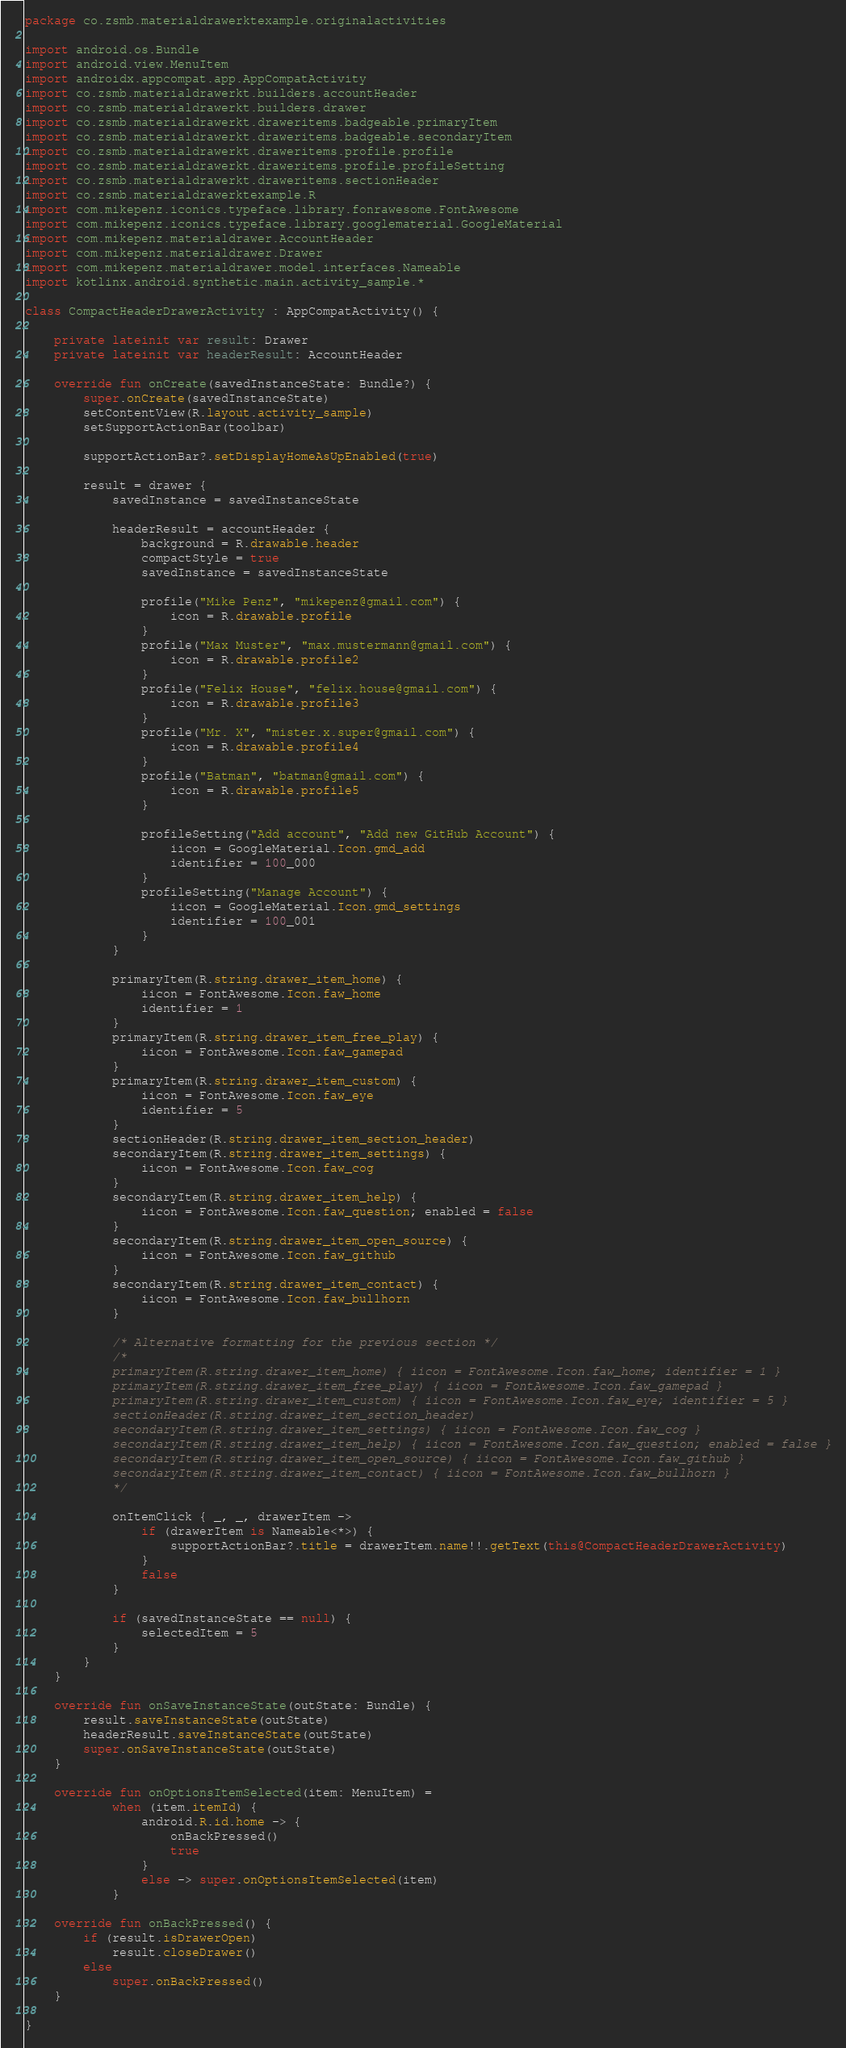<code> <loc_0><loc_0><loc_500><loc_500><_Kotlin_>package co.zsmb.materialdrawerktexample.originalactivities

import android.os.Bundle
import android.view.MenuItem
import androidx.appcompat.app.AppCompatActivity
import co.zsmb.materialdrawerkt.builders.accountHeader
import co.zsmb.materialdrawerkt.builders.drawer
import co.zsmb.materialdrawerkt.draweritems.badgeable.primaryItem
import co.zsmb.materialdrawerkt.draweritems.badgeable.secondaryItem
import co.zsmb.materialdrawerkt.draweritems.profile.profile
import co.zsmb.materialdrawerkt.draweritems.profile.profileSetting
import co.zsmb.materialdrawerkt.draweritems.sectionHeader
import co.zsmb.materialdrawerktexample.R
import com.mikepenz.iconics.typeface.library.fonrawesome.FontAwesome
import com.mikepenz.iconics.typeface.library.googlematerial.GoogleMaterial
import com.mikepenz.materialdrawer.AccountHeader
import com.mikepenz.materialdrawer.Drawer
import com.mikepenz.materialdrawer.model.interfaces.Nameable
import kotlinx.android.synthetic.main.activity_sample.*

class CompactHeaderDrawerActivity : AppCompatActivity() {

    private lateinit var result: Drawer
    private lateinit var headerResult: AccountHeader

    override fun onCreate(savedInstanceState: Bundle?) {
        super.onCreate(savedInstanceState)
        setContentView(R.layout.activity_sample)
        setSupportActionBar(toolbar)

        supportActionBar?.setDisplayHomeAsUpEnabled(true)

        result = drawer {
            savedInstance = savedInstanceState

            headerResult = accountHeader {
                background = R.drawable.header
                compactStyle = true
                savedInstance = savedInstanceState

                profile("Mike Penz", "mikepenz@gmail.com") {
                    icon = R.drawable.profile
                }
                profile("Max Muster", "max.mustermann@gmail.com") {
                    icon = R.drawable.profile2
                }
                profile("Felix House", "felix.house@gmail.com") {
                    icon = R.drawable.profile3
                }
                profile("Mr. X", "mister.x.super@gmail.com") {
                    icon = R.drawable.profile4
                }
                profile("Batman", "batman@gmail.com") {
                    icon = R.drawable.profile5
                }

                profileSetting("Add account", "Add new GitHub Account") {
                    iicon = GoogleMaterial.Icon.gmd_add
                    identifier = 100_000
                }
                profileSetting("Manage Account") {
                    iicon = GoogleMaterial.Icon.gmd_settings
                    identifier = 100_001
                }
            }

            primaryItem(R.string.drawer_item_home) {
                iicon = FontAwesome.Icon.faw_home
                identifier = 1
            }
            primaryItem(R.string.drawer_item_free_play) {
                iicon = FontAwesome.Icon.faw_gamepad
            }
            primaryItem(R.string.drawer_item_custom) {
                iicon = FontAwesome.Icon.faw_eye
                identifier = 5
            }
            sectionHeader(R.string.drawer_item_section_header)
            secondaryItem(R.string.drawer_item_settings) {
                iicon = FontAwesome.Icon.faw_cog
            }
            secondaryItem(R.string.drawer_item_help) {
                iicon = FontAwesome.Icon.faw_question; enabled = false
            }
            secondaryItem(R.string.drawer_item_open_source) {
                iicon = FontAwesome.Icon.faw_github
            }
            secondaryItem(R.string.drawer_item_contact) {
                iicon = FontAwesome.Icon.faw_bullhorn
            }

            /* Alternative formatting for the previous section */
            /*
            primaryItem(R.string.drawer_item_home) { iicon = FontAwesome.Icon.faw_home; identifier = 1 }
            primaryItem(R.string.drawer_item_free_play) { iicon = FontAwesome.Icon.faw_gamepad }
            primaryItem(R.string.drawer_item_custom) { iicon = FontAwesome.Icon.faw_eye; identifier = 5 }
            sectionHeader(R.string.drawer_item_section_header)
            secondaryItem(R.string.drawer_item_settings) { iicon = FontAwesome.Icon.faw_cog }
            secondaryItem(R.string.drawer_item_help) { iicon = FontAwesome.Icon.faw_question; enabled = false }
            secondaryItem(R.string.drawer_item_open_source) { iicon = FontAwesome.Icon.faw_github }
            secondaryItem(R.string.drawer_item_contact) { iicon = FontAwesome.Icon.faw_bullhorn }
            */

            onItemClick { _, _, drawerItem ->
                if (drawerItem is Nameable<*>) {
                    supportActionBar?.title = drawerItem.name!!.getText(this@CompactHeaderDrawerActivity)
                }
                false
            }

            if (savedInstanceState == null) {
                selectedItem = 5
            }
        }
    }

    override fun onSaveInstanceState(outState: Bundle) {
        result.saveInstanceState(outState)
        headerResult.saveInstanceState(outState)
        super.onSaveInstanceState(outState)
    }

    override fun onOptionsItemSelected(item: MenuItem) =
            when (item.itemId) {
                android.R.id.home -> {
                    onBackPressed()
                    true
                }
                else -> super.onOptionsItemSelected(item)
            }

    override fun onBackPressed() {
        if (result.isDrawerOpen)
            result.closeDrawer()
        else
            super.onBackPressed()
    }

}
</code> 